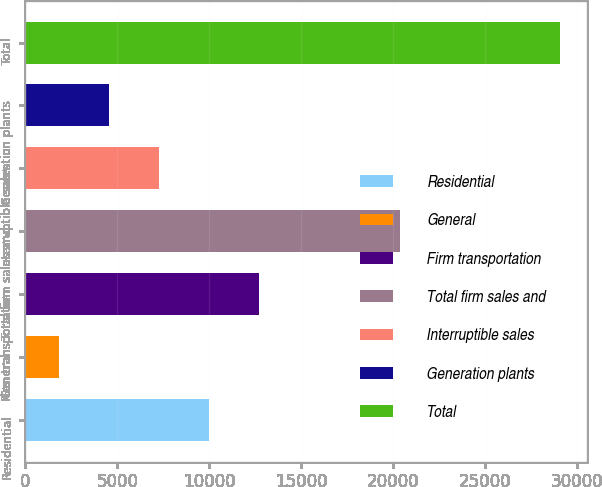Convert chart to OTSL. <chart><loc_0><loc_0><loc_500><loc_500><bar_chart><fcel>Residential<fcel>General<fcel>Firm transportation<fcel>Total firm sales and<fcel>Interruptible sales<fcel>Generation plants<fcel>Total<nl><fcel>10000.6<fcel>1816<fcel>12728.8<fcel>20355<fcel>7272.4<fcel>4544.2<fcel>29098<nl></chart> 